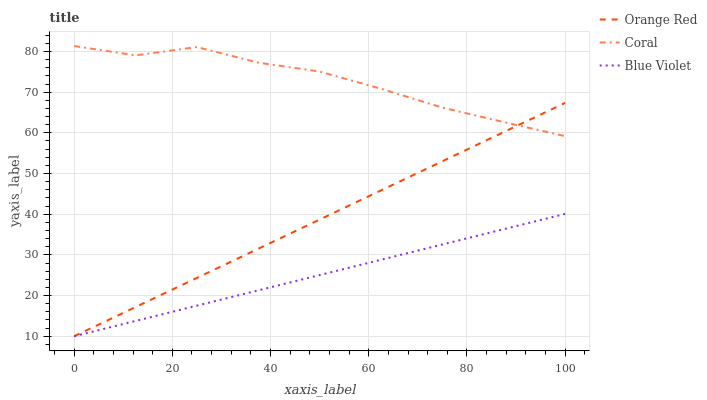Does Blue Violet have the minimum area under the curve?
Answer yes or no. Yes. Does Coral have the maximum area under the curve?
Answer yes or no. Yes. Does Orange Red have the minimum area under the curve?
Answer yes or no. No. Does Orange Red have the maximum area under the curve?
Answer yes or no. No. Is Blue Violet the smoothest?
Answer yes or no. Yes. Is Coral the roughest?
Answer yes or no. Yes. Is Orange Red the smoothest?
Answer yes or no. No. Is Orange Red the roughest?
Answer yes or no. No. Does Orange Red have the lowest value?
Answer yes or no. Yes. Does Coral have the highest value?
Answer yes or no. Yes. Does Orange Red have the highest value?
Answer yes or no. No. Is Blue Violet less than Coral?
Answer yes or no. Yes. Is Coral greater than Blue Violet?
Answer yes or no. Yes. Does Coral intersect Orange Red?
Answer yes or no. Yes. Is Coral less than Orange Red?
Answer yes or no. No. Is Coral greater than Orange Red?
Answer yes or no. No. Does Blue Violet intersect Coral?
Answer yes or no. No. 